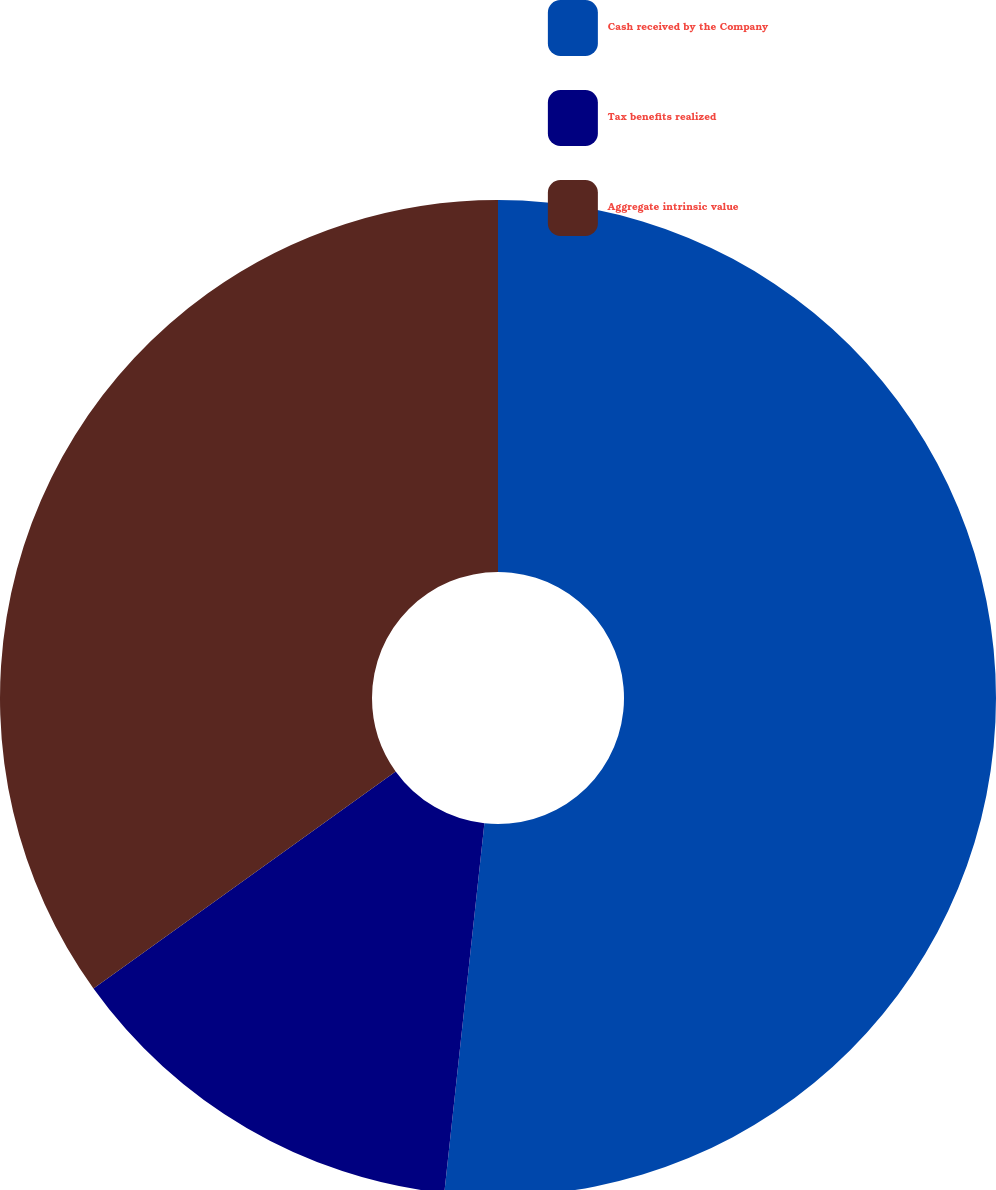Convert chart to OTSL. <chart><loc_0><loc_0><loc_500><loc_500><pie_chart><fcel>Cash received by the Company<fcel>Tax benefits realized<fcel>Aggregate intrinsic value<nl><fcel>51.72%<fcel>13.37%<fcel>34.91%<nl></chart> 